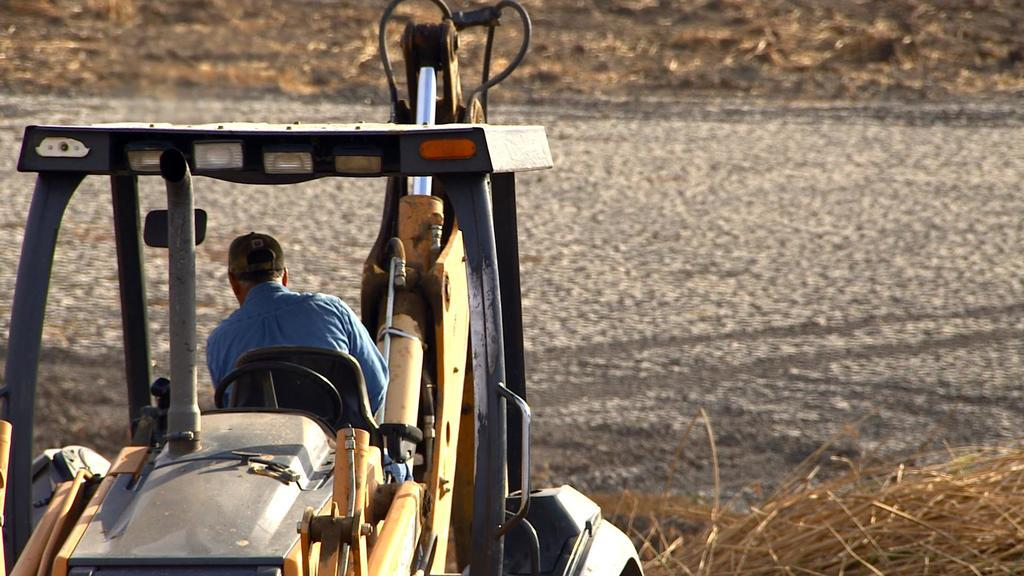What is the person in the image doing? The person is riding a vehicle in the image. What is the person wearing on their upper body? The person is wearing a blue shirt in the image. What type of headwear is the person wearing? The person is wearing a cap in the image. What can be seen on the right side of the image? Dry grass is present on the right side of the image. What type of background is visible in the image? The background of the image consists of land. What type of brain is visible in the image? There is no brain visible in the image; it features a person riding a vehicle. What type of vest is the person wearing in the image? The person is not wearing a vest in the image; they are wearing a blue shirt and a cap. 